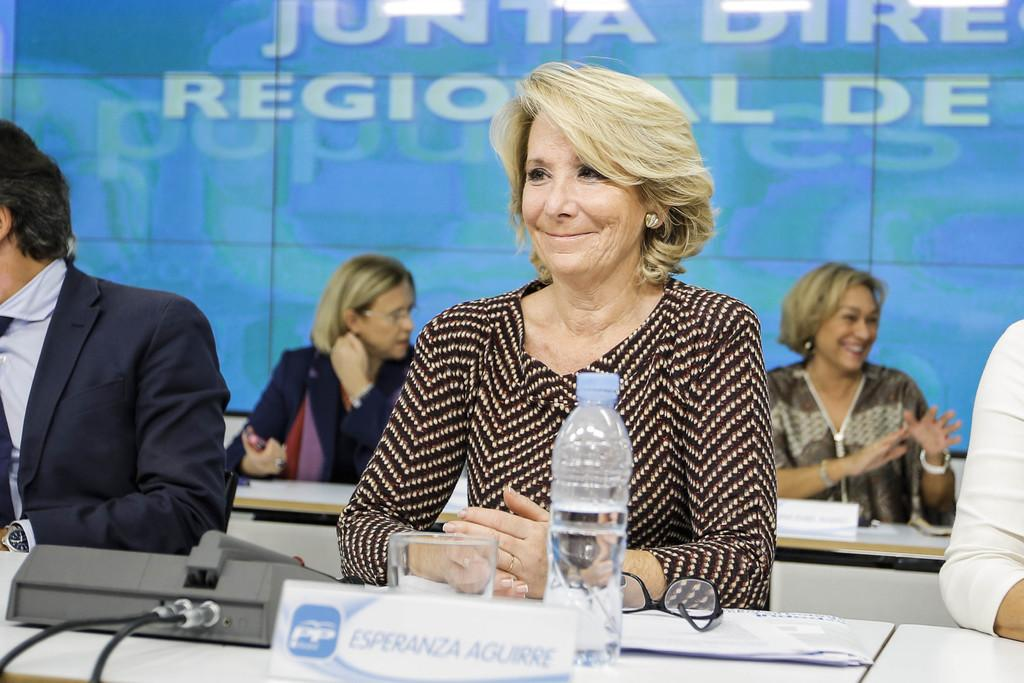What are the people in the image doing? The people in the image are sitting. What objects are present in the image that might be used for seating or eating? There are tables in the image. What can be seen on one of the tables? There is a projector, a bottle, spectacles, and a paper on one of the tables. Can you see a mountain in the image? There is no mountain present in the image. What type of push is required to move the projector in the image? The projector in the image is not in motion, so there is no need to push it. 